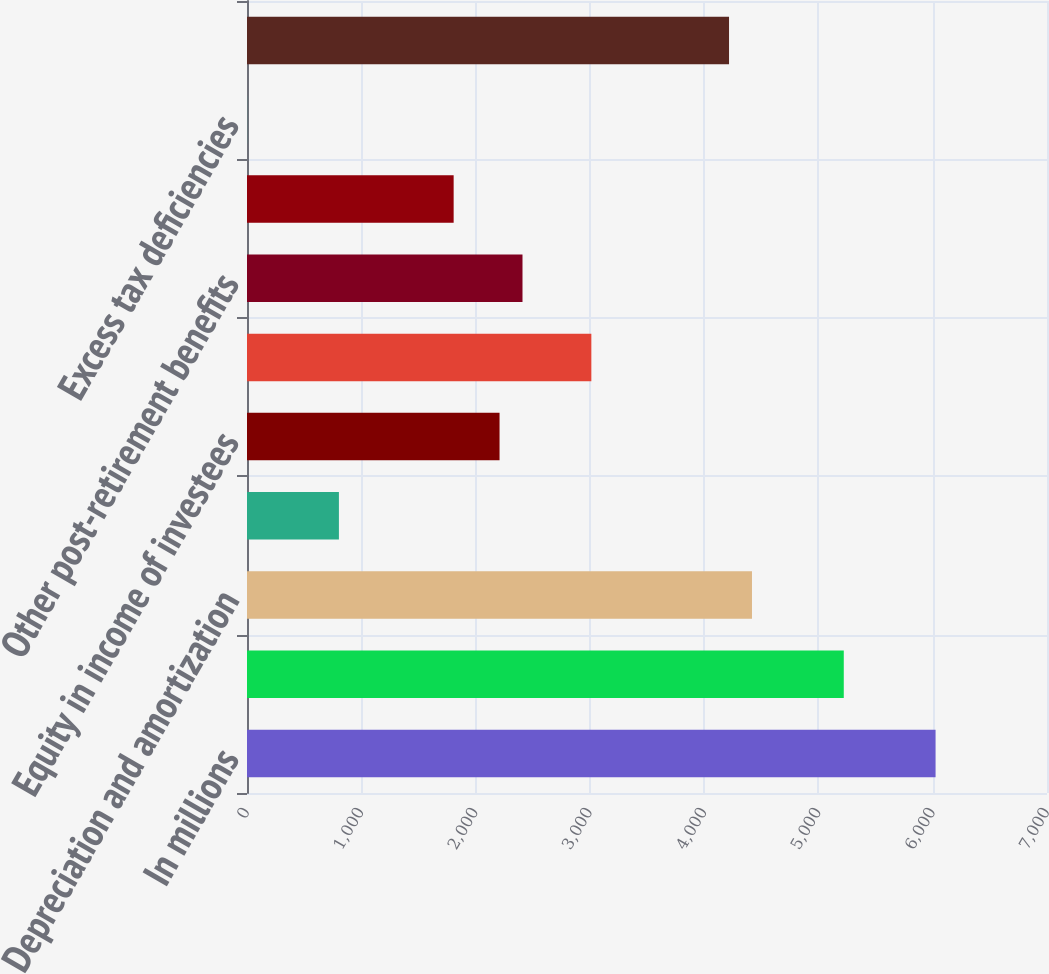<chart> <loc_0><loc_0><loc_500><loc_500><bar_chart><fcel>In millions<fcel>Net income<fcel>Depreciation and amortization<fcel>Deferred income tax provision<fcel>Equity in income of investees<fcel>Pension expense net of pension<fcel>Other post-retirement benefits<fcel>Stock-based compensation<fcel>Excess tax deficiencies<fcel>Capital expenditures<nl><fcel>6025<fcel>5221.8<fcel>4418.6<fcel>804.2<fcel>2209.8<fcel>3013<fcel>2410.6<fcel>1808.2<fcel>1<fcel>4217.8<nl></chart> 